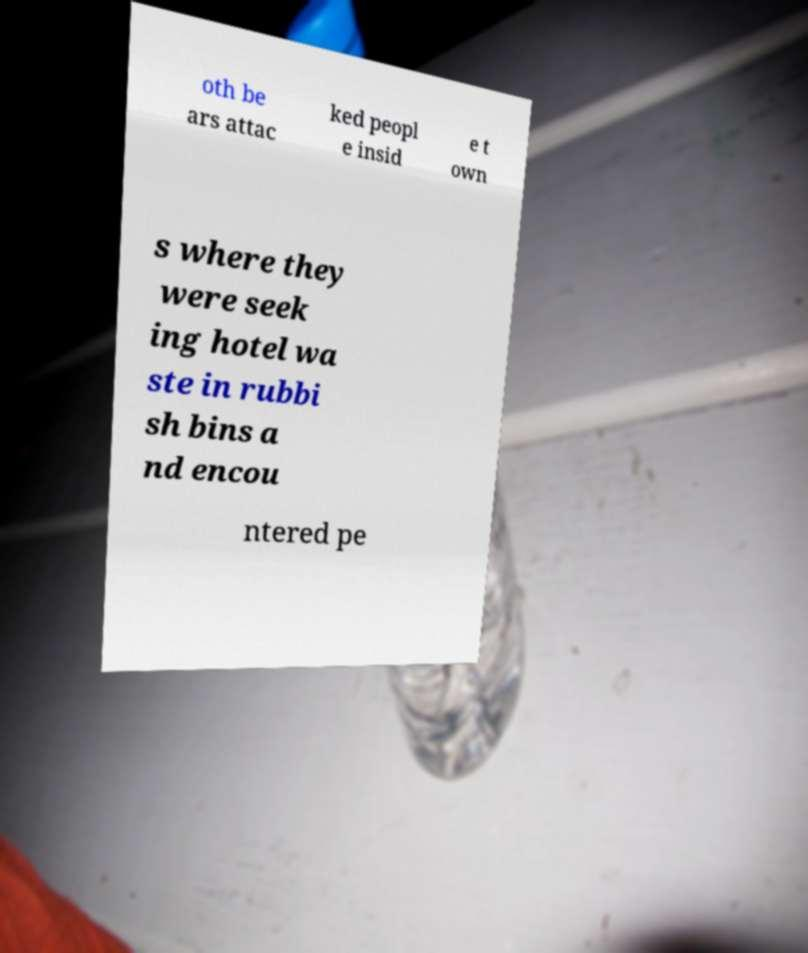Please read and relay the text visible in this image. What does it say? oth be ars attac ked peopl e insid e t own s where they were seek ing hotel wa ste in rubbi sh bins a nd encou ntered pe 